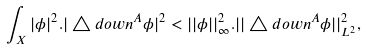Convert formula to latex. <formula><loc_0><loc_0><loc_500><loc_500>\int _ { X } | \phi | ^ { 2 } . | \triangle d o w n ^ { A } \phi | ^ { 2 } < | | \phi | | ^ { 2 } _ { \infty } . | | \triangle d o w n ^ { A } \phi | | ^ { 2 } _ { L ^ { 2 } } ,</formula> 